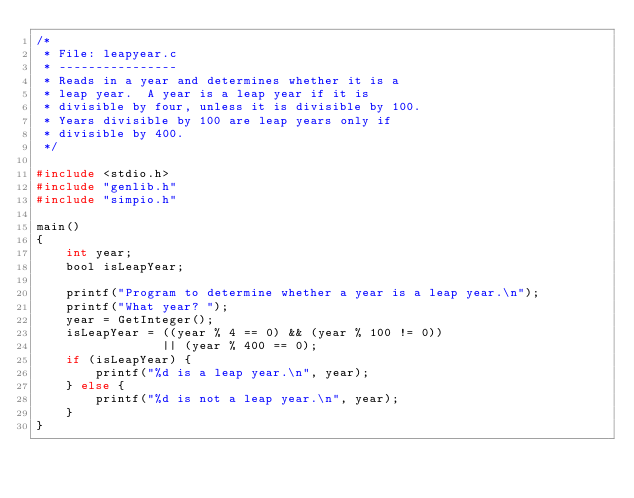<code> <loc_0><loc_0><loc_500><loc_500><_C_>/*
 * File: leapyear.c
 * ----------------
 * Reads in a year and determines whether it is a
 * leap year.  A year is a leap year if it is
 * divisible by four, unless it is divisible by 100.
 * Years divisible by 100 are leap years only if
 * divisible by 400.
 */

#include <stdio.h>
#include "genlib.h"
#include "simpio.h"

main()
{
    int year;
    bool isLeapYear;

    printf("Program to determine whether a year is a leap year.\n");
    printf("What year? ");
    year = GetInteger();
    isLeapYear = ((year % 4 == 0) && (year % 100 != 0))
                 || (year % 400 == 0);
    if (isLeapYear) {
        printf("%d is a leap year.\n", year);
    } else {
        printf("%d is not a leap year.\n", year);
    }
}
</code> 